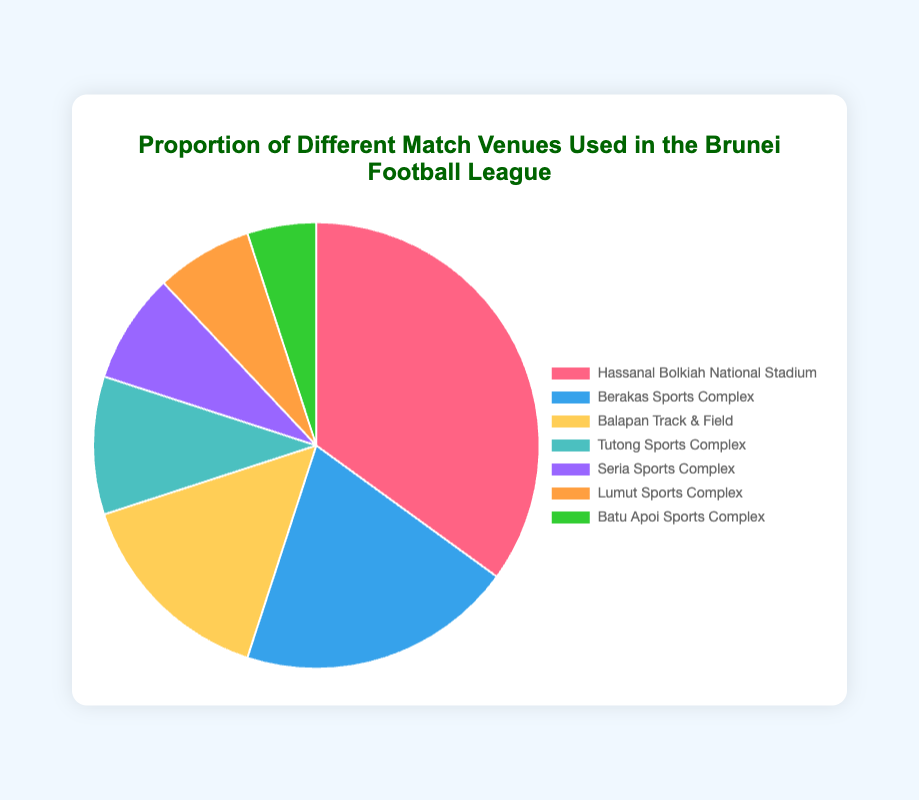What is the proportion of matches played at the Hassanal Bolkiah National Stadium? The slice for the Hassanal Bolkiah National Stadium shows 35%.
Answer: 35% Which venue hosts the least proportion of matches? The smallest slice, representing 5%, is labeled Batu Apoi Sports Complex.
Answer: Batu Apoi Sports Complex What is the combined proportion of matches played at Seria Sports Complex and Lumut Sports Complex? Seria Sports Complex is 8% and Lumut Sports Complex is 7%; when combined, the total is 8% + 7% = 15%.
Answer: 15% Which venue has a higher proportion of matches, Balapan Track & Field or Tutong Sports Complex? The Balapan Track & Field slice is 15%, while the Tutong Sports Complex slice is 10%. Therefore, Balapan Track & Field has a higher proportion.
Answer: Balapan Track & Field What is the difference in the proportion of matches between the venue hosting the most and the least matches? The largest slice, Hassanal Bolkiah National Stadium, is 35%, and the smallest slice, Batu Apoi Sports Complex, is 5%. The difference is 35% - 5% = 30%.
Answer: 30% Which three venues combined make up the majority proportion of matches? Adding the top three proportions: Hassanal Bolkiah National Stadium (35%), Berakas Sports Complex (20%), and Balapan Track & Field (15%) gives a total of 35% + 20% + 15% = 70%. This is more than 50%, so these three venues combined make up the majority.
Answer: Hassanal Bolkiah National Stadium, Berakas Sports Complex, Balapan Track & Field How much more is the proportion of matches at Berakas Sports Complex compared to Lumut Sports Complex? The proportion at Berakas Sports Complex is 20%, and at Lumut Sports Complex, it is 7%. The difference is 20% - 7% = 13%.
Answer: 13% Is the proportion of matches at the Hassanal Bolkiah National Stadium more than double that of Berakas Sports Complex? The proportion at Hassanal Bolkiah National Stadium is 35%, and at Berakas Sports Complex, it is 20%. Double 20% is 40%, which is greater than 35%. Therefore, the Hassanal Bolkiah National Stadium is not hosting more than double the matches of Berakas Sports Complex.
Answer: No What is the average proportion of matches among all venues? The proportions are 35%, 20%, 15%, 10%, 8%, 7%, and 5%. Adding them together gives 35 + 20 + 15 + 10 + 8 + 7 + 5 = 100. There are 7 venues, so the average is 100/7 ≈ 14.29%.
Answer: 14.29% 